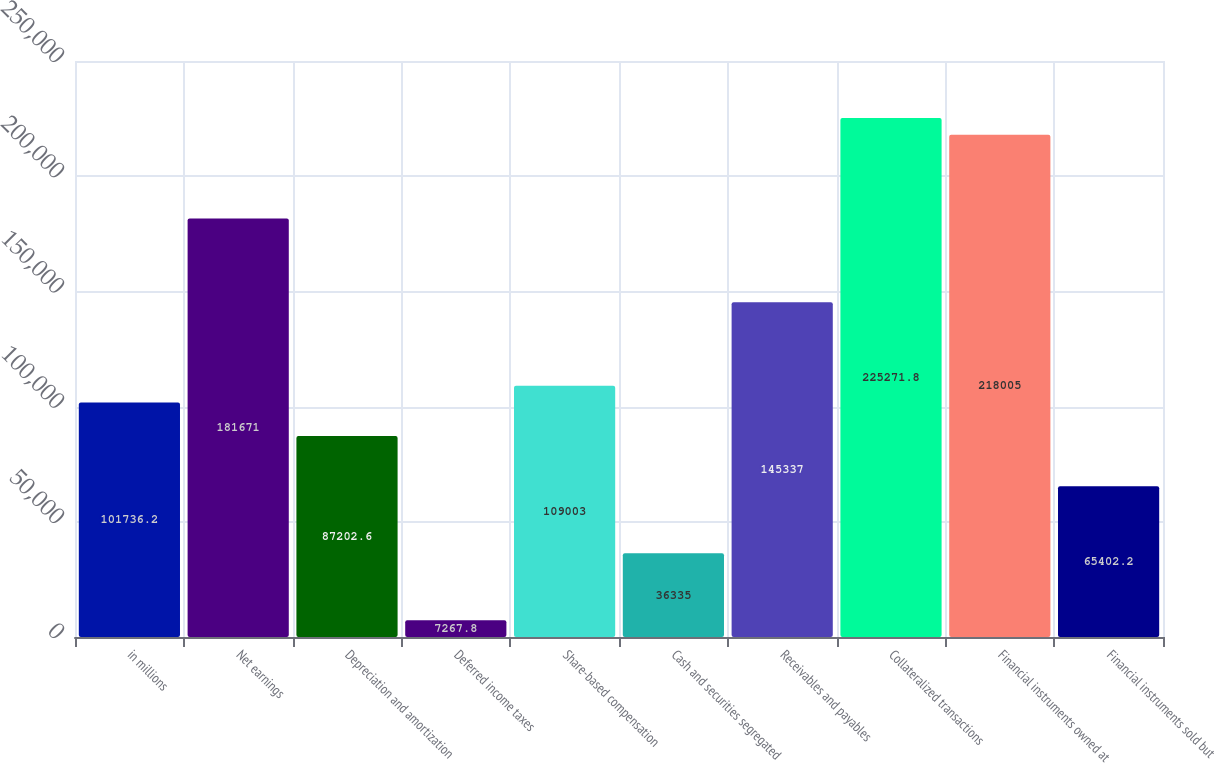Convert chart. <chart><loc_0><loc_0><loc_500><loc_500><bar_chart><fcel>in millions<fcel>Net earnings<fcel>Depreciation and amortization<fcel>Deferred income taxes<fcel>Share-based compensation<fcel>Cash and securities segregated<fcel>Receivables and payables<fcel>Collateralized transactions<fcel>Financial instruments owned at<fcel>Financial instruments sold but<nl><fcel>101736<fcel>181671<fcel>87202.6<fcel>7267.8<fcel>109003<fcel>36335<fcel>145337<fcel>225272<fcel>218005<fcel>65402.2<nl></chart> 